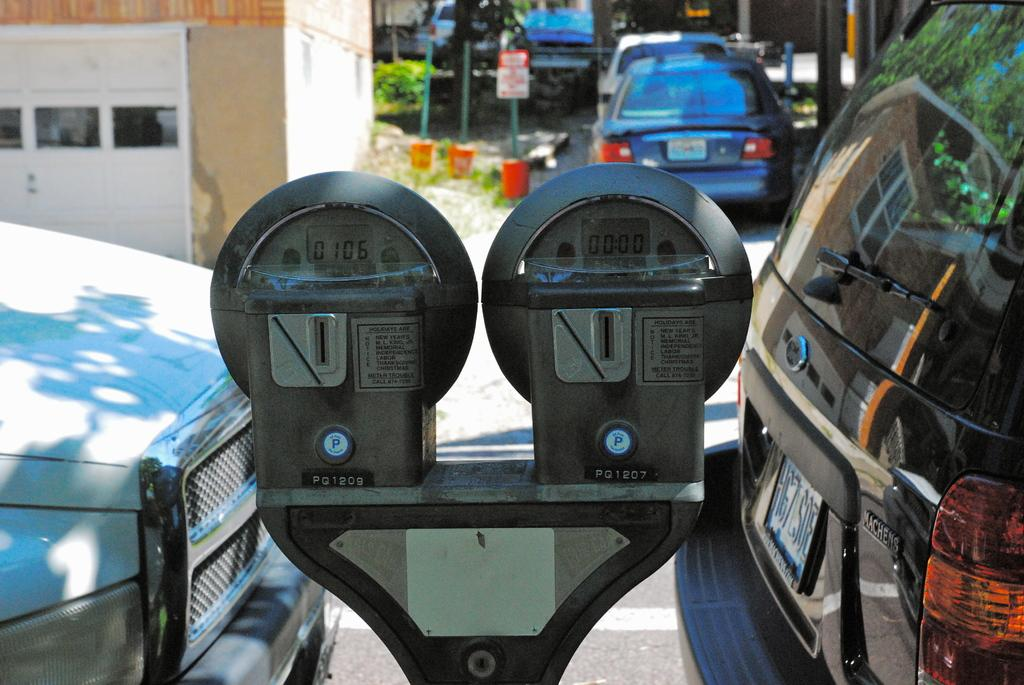<image>
Give a short and clear explanation of the subsequent image. Parking meter number PQ1209 shows 0106 on its screen. 